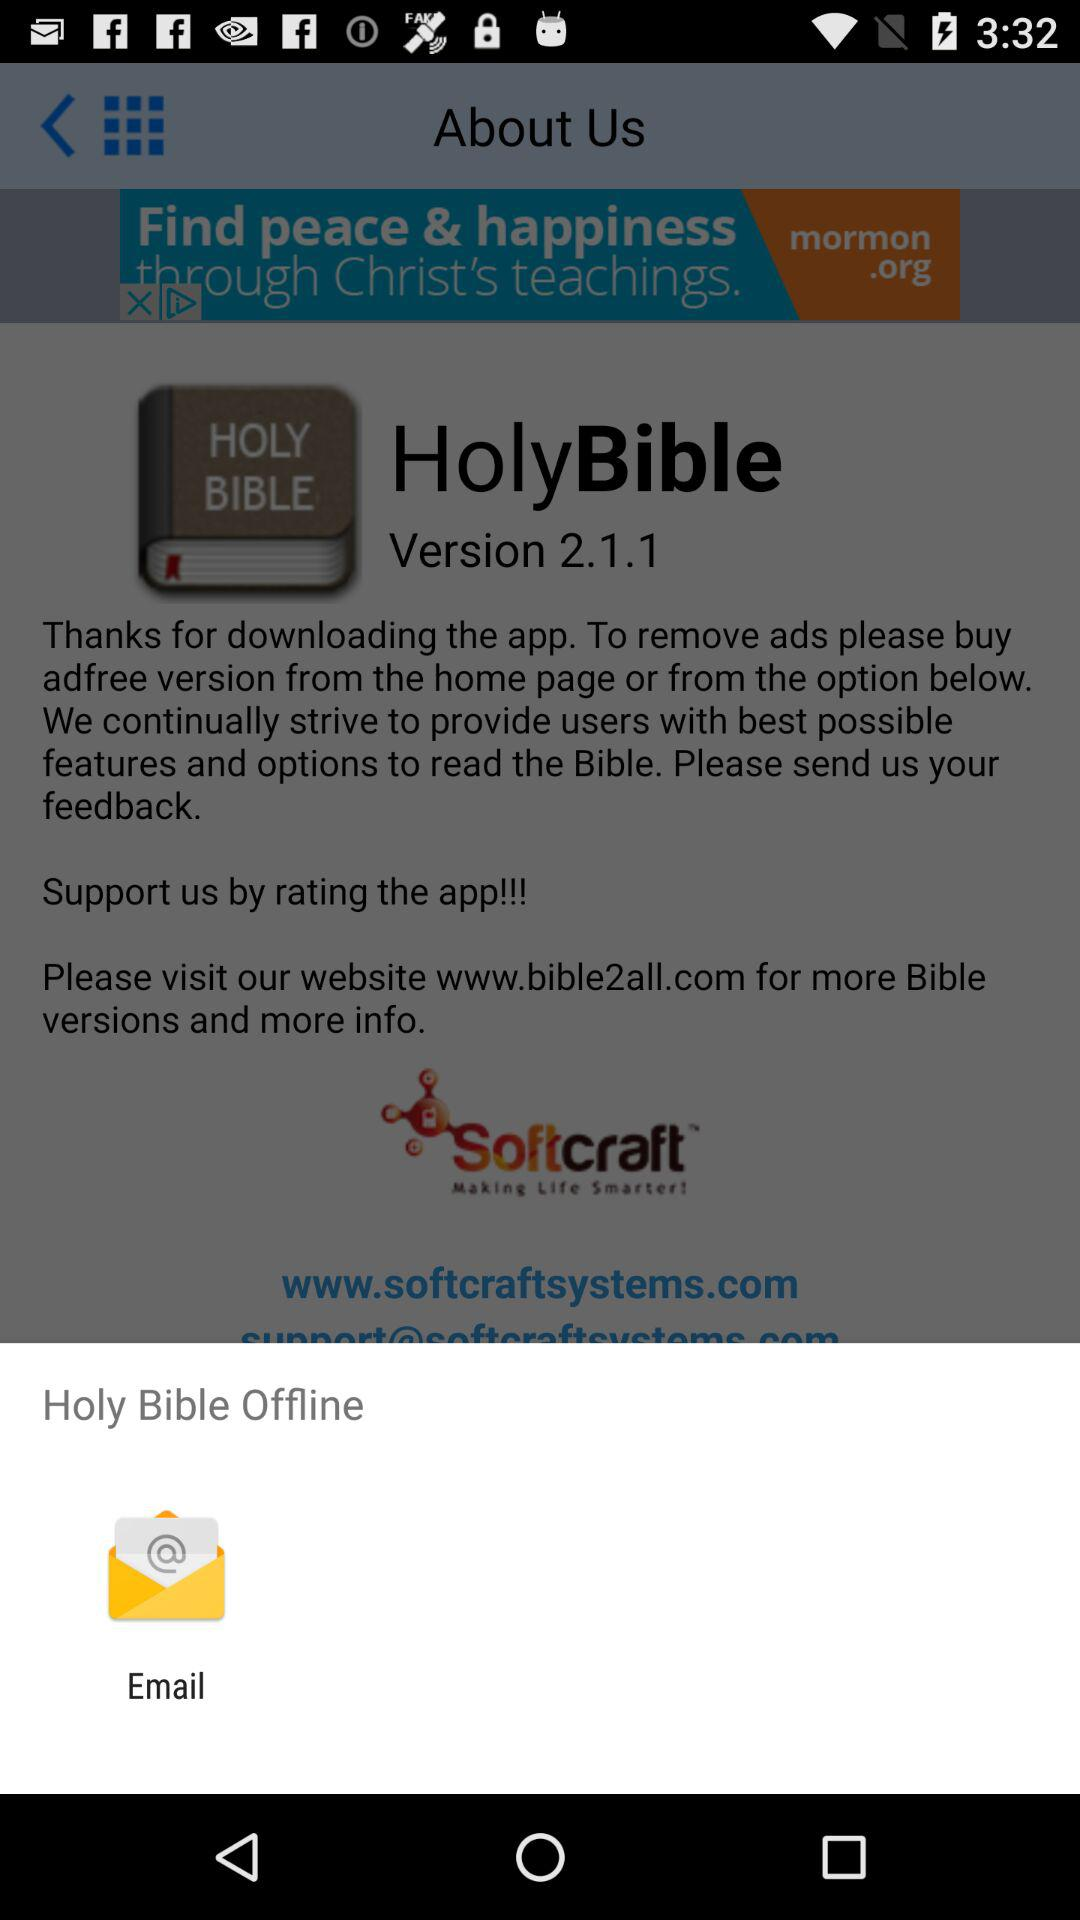What is the website of the "HolyBible"? The website is www.bible2all.com. 